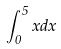<formula> <loc_0><loc_0><loc_500><loc_500>\int _ { 0 } ^ { 5 } x d x</formula> 